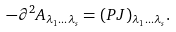Convert formula to latex. <formula><loc_0><loc_0><loc_500><loc_500>- \partial ^ { 2 } A _ { \lambda _ { 1 } \dots \lambda _ { s } } = ( P J ) _ { \lambda _ { 1 } \dots \lambda _ { s } } .</formula> 